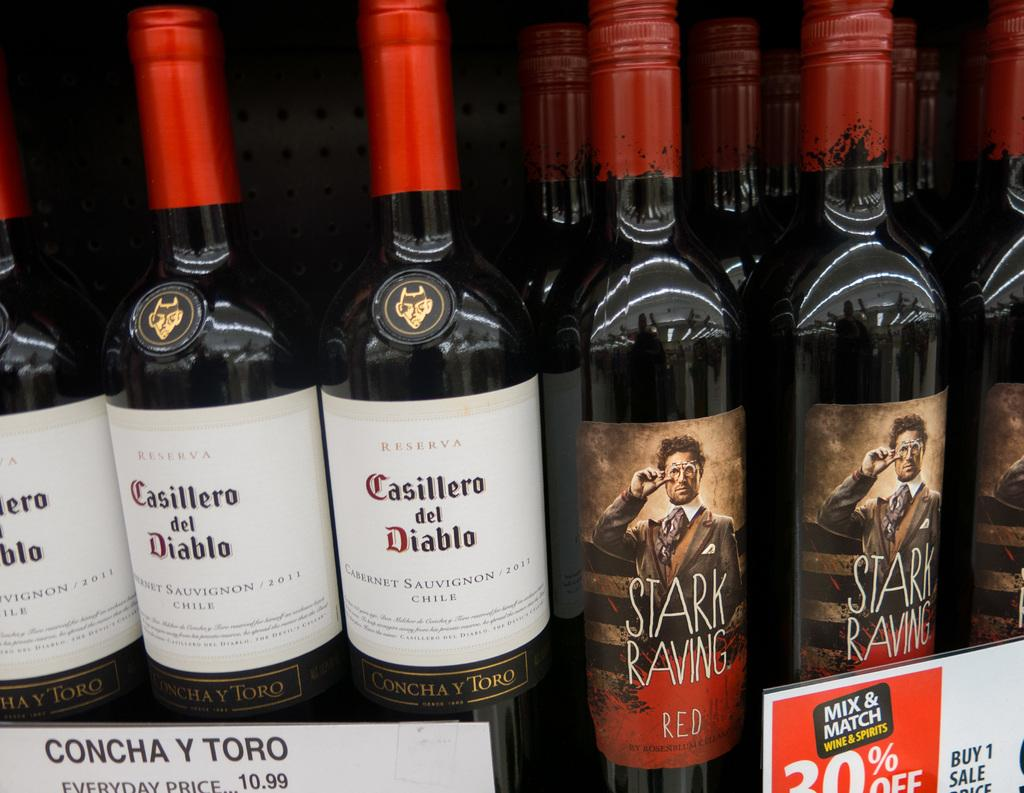<image>
Write a terse but informative summary of the picture. A bottle from BrewDog that is called Hops Kill Nazis. 